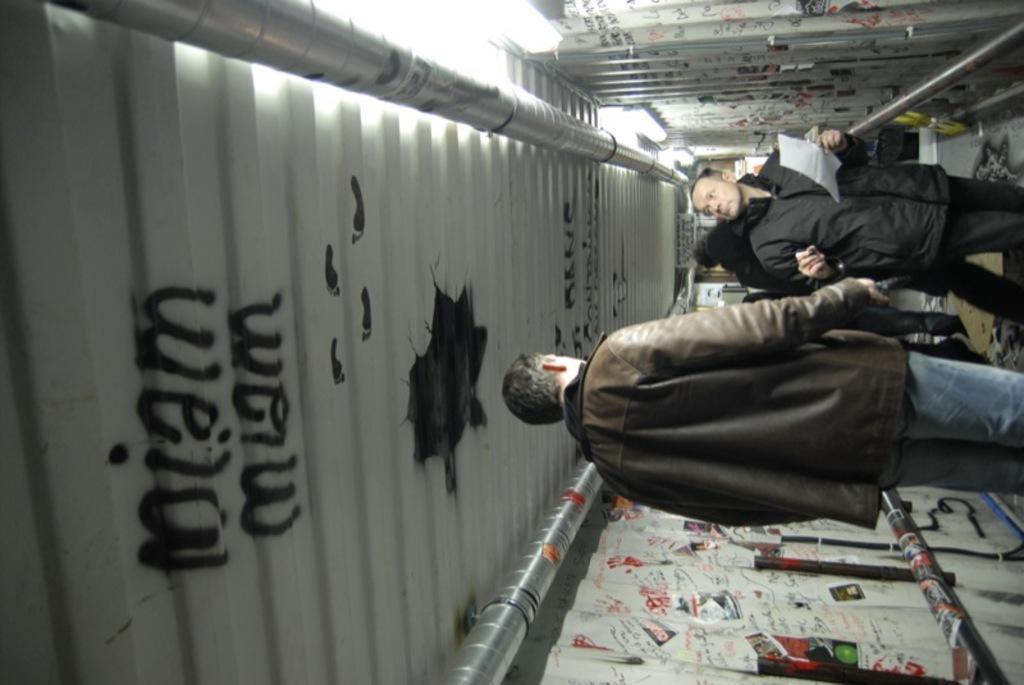How would you summarize this image in a sentence or two? In this picture I can see group of people standing, a person holding a paper, there are some scribbling and papers on the walls, there are lights, pipes, iron rods, and there are some words on the roof. 